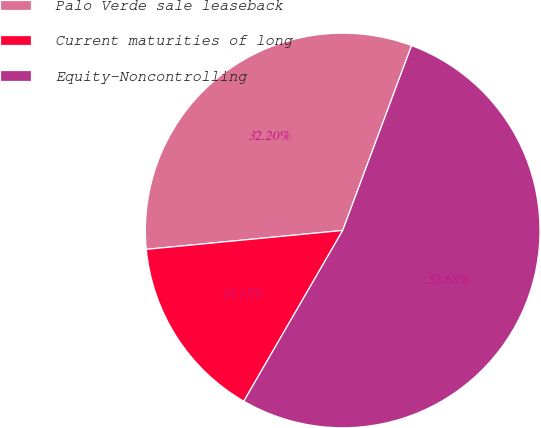<chart> <loc_0><loc_0><loc_500><loc_500><pie_chart><fcel>Palo Verde sale leaseback<fcel>Current maturities of long<fcel>Equity-Noncontrolling<nl><fcel>32.2%<fcel>15.12%<fcel>52.68%<nl></chart> 